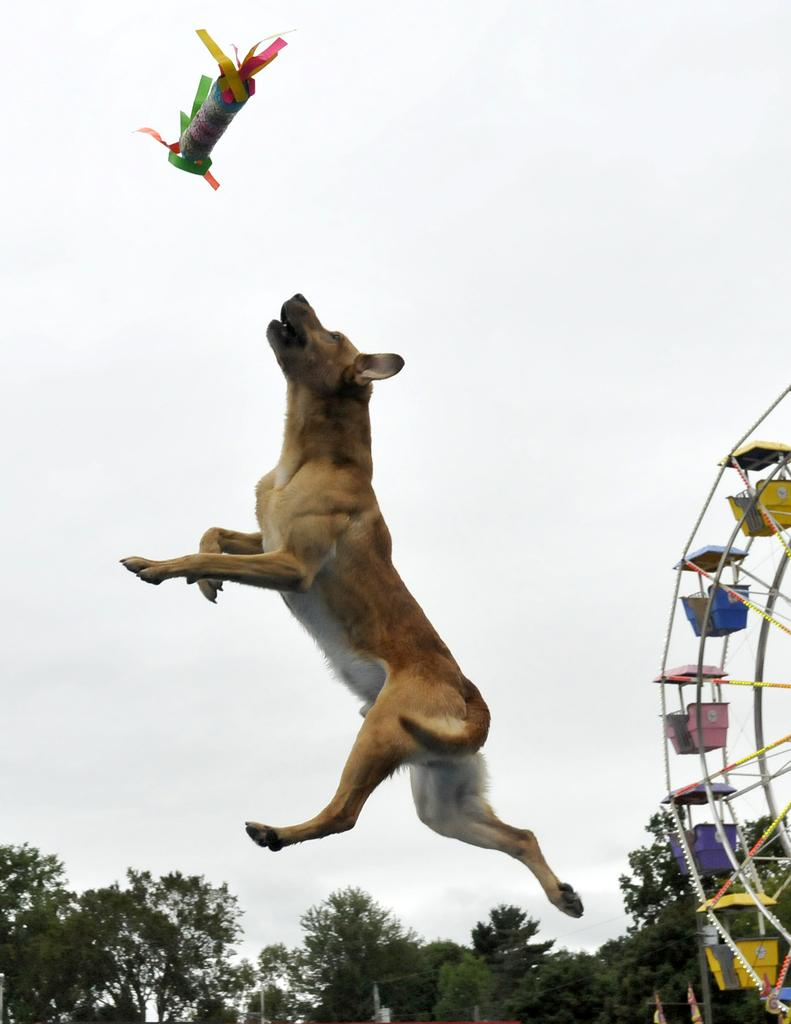What animal is present in the image? There is a dog in the image. What is the dog doing in the image? The dog is jumping and trying to catch an object. What can be seen in the background of the image? There are trees, a giant wheel, and the sky visible in the background of the image. What type of star can be seen in the image? There is no star visible in the image; it features a dog jumping and trying to catch an object, with trees, a giant wheel, and the sky in the background. 